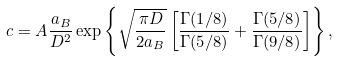<formula> <loc_0><loc_0><loc_500><loc_500>c = A \frac { a _ { B } } { D ^ { 2 } } \exp \left \{ \sqrt { \frac { \pi D } { 2 a _ { B } } } \left [ \frac { \Gamma ( 1 / 8 ) } { \Gamma ( 5 / 8 ) } + \frac { \Gamma ( 5 / 8 ) } { \Gamma ( 9 / 8 ) } \right ] \right \} ,</formula> 